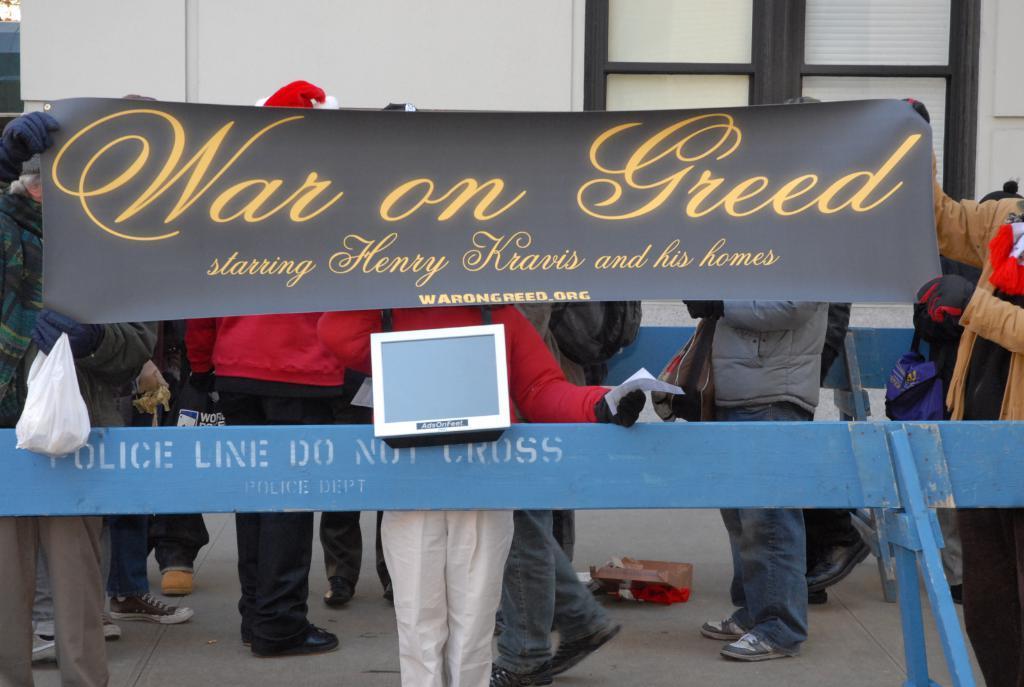Describe this image in one or two sentences. In this image there are many people standing. In front of them there is a railing. They are holding a banner. There is text on the banner. In the background there is a wall. 